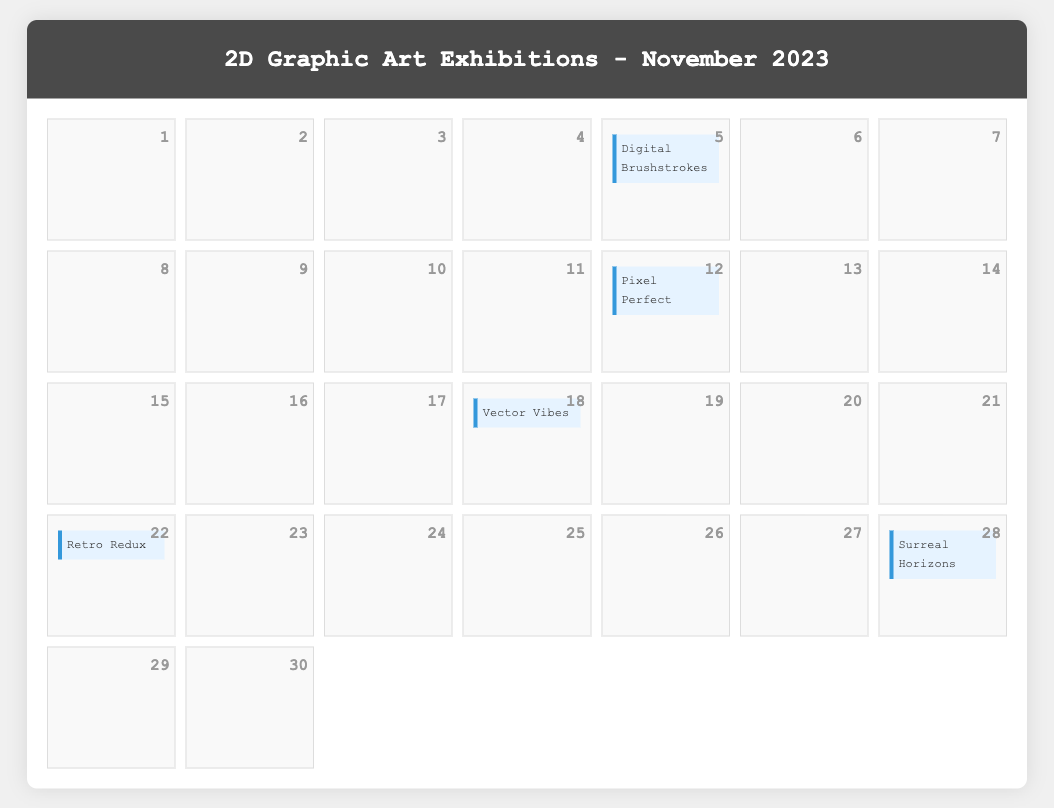what is the name of the exhibition on November 5? The document provides the name of the exhibition held on November 5 as "Digital Brushstrokes."
Answer: Digital Brushstrokes who is the artist for the "Pixel Perfect" exhibition? The document specifies Michael Laurent as the artist for the "Pixel Perfect" exhibition scheduled for November 12.
Answer: Michael Laurent what software was mentioned in the "Digital Brushstrokes" exhibition description? The exhibition description for "Digital Brushstrokes" lists "Adobe Photoshop and Corel Painter" as the software used.
Answer: Adobe Photoshop and Corel Painter which exhibition takes place in Los Angeles? According to the document, "Surreal Horizons" is the exhibition taking place in Los Angeles on November 28.
Answer: Surreal Horizons how many exhibitions are scheduled for November 2023? The document outlines a total of six exhibitions occurring in November 2023.
Answer: 6 what type of art is highlighted in "Vector Vibes"? "Vector Vibes" emphasizes vector art illustrations as noted in the exhibition details.
Answer: vector art illustrations which day has an event focusing on retro-styled graphic art? The exhibition "Retro Redux," which focuses on retro-styled graphic art, is scheduled for November 22.
Answer: November 22 what is the date for "Vector Vibes"? The exhibition "Vector Vibes" is set to take place on November 18, as indicated in the document.
Answer: November 18 what location hosts the "Surreal Horizons" exhibition? The document states that "Surreal Horizons" is hosted at Dreamscape Gallery in Los Angeles.
Answer: Dreamscape Gallery, Los Angeles 